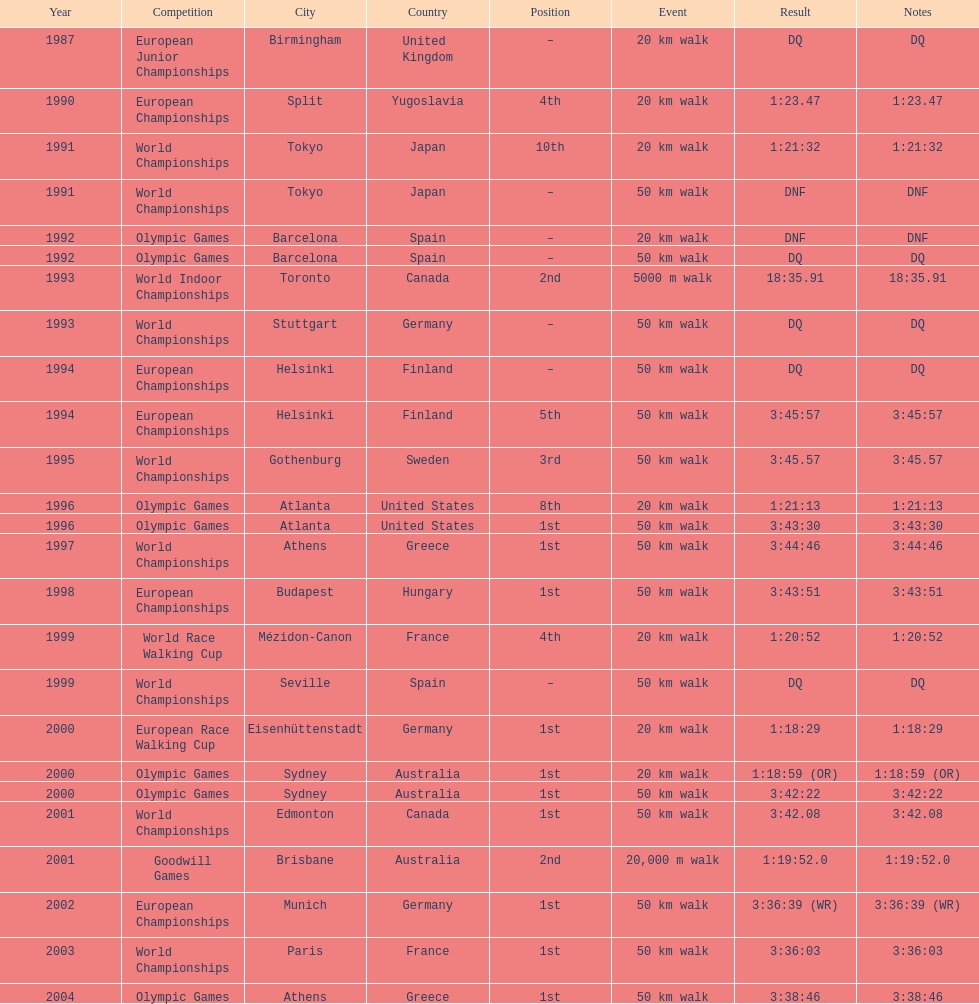How many times was first place listed as the position? 10. 